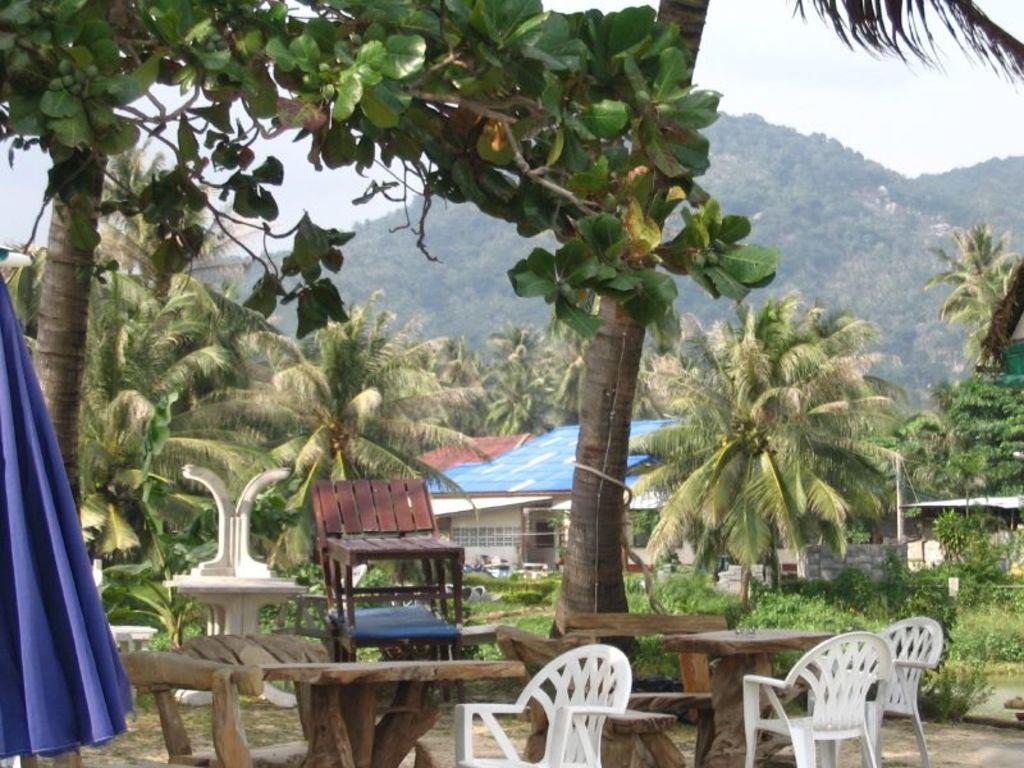Please provide a concise description of this image. In this picture we can see some wooden table and chairs. In the front we can see blue and white shed house and many coconut trees. In the background we can see the mountain full of trees. 